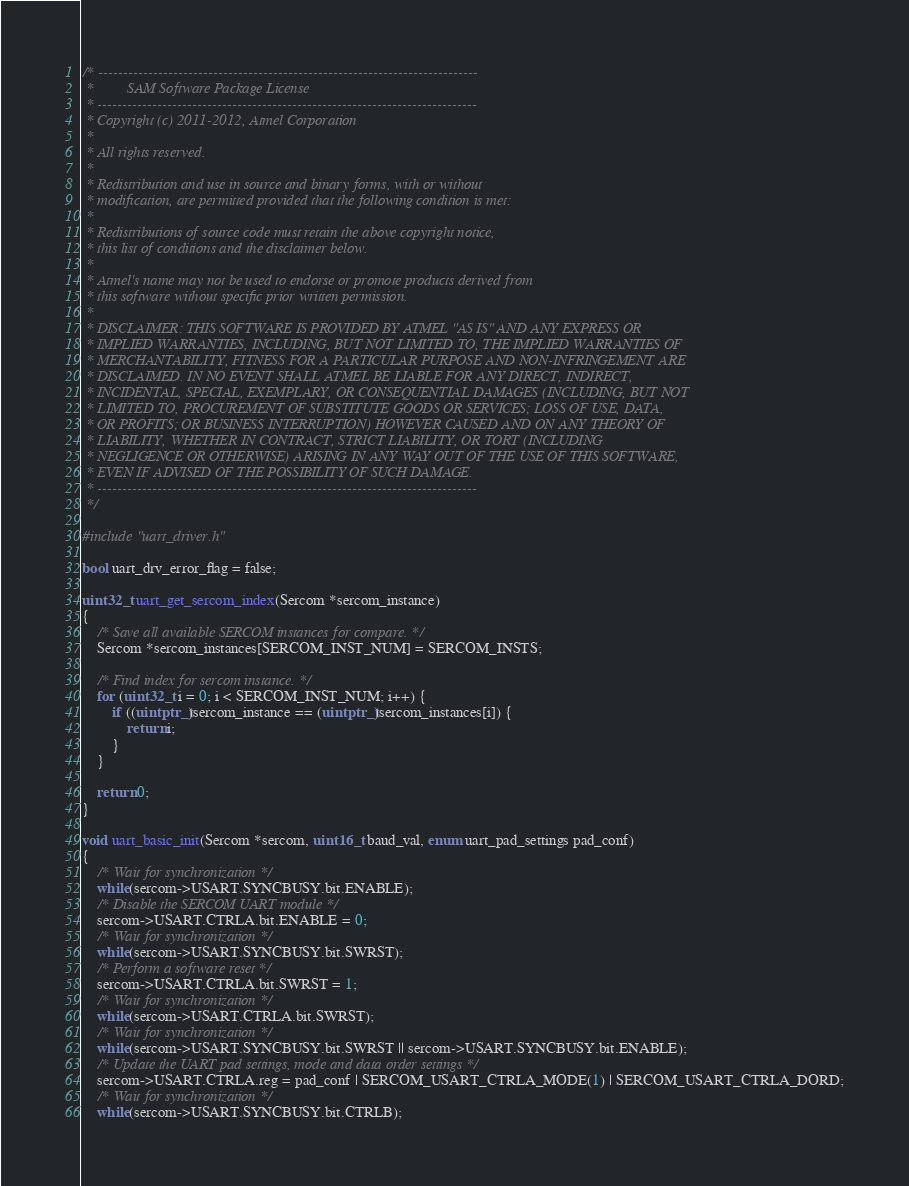Convert code to text. <code><loc_0><loc_0><loc_500><loc_500><_C_>/* ----------------------------------------------------------------------------
 *         SAM Software Package License
 * ----------------------------------------------------------------------------
 * Copyright (c) 2011-2012, Atmel Corporation
 *
 * All rights reserved.
 *
 * Redistribution and use in source and binary forms, with or without
 * modification, are permitted provided that the following condition is met:
 *
 * Redistributions of source code must retain the above copyright notice,
 * this list of conditions and the disclaimer below.
 *
 * Atmel's name may not be used to endorse or promote products derived from
 * this software without specific prior written permission.
 *
 * DISCLAIMER: THIS SOFTWARE IS PROVIDED BY ATMEL "AS IS" AND ANY EXPRESS OR
 * IMPLIED WARRANTIES, INCLUDING, BUT NOT LIMITED TO, THE IMPLIED WARRANTIES OF
 * MERCHANTABILITY, FITNESS FOR A PARTICULAR PURPOSE AND NON-INFRINGEMENT ARE
 * DISCLAIMED. IN NO EVENT SHALL ATMEL BE LIABLE FOR ANY DIRECT, INDIRECT,
 * INCIDENTAL, SPECIAL, EXEMPLARY, OR CONSEQUENTIAL DAMAGES (INCLUDING, BUT NOT
 * LIMITED TO, PROCUREMENT OF SUBSTITUTE GOODS OR SERVICES; LOSS OF USE, DATA,
 * OR PROFITS; OR BUSINESS INTERRUPTION) HOWEVER CAUSED AND ON ANY THEORY OF
 * LIABILITY, WHETHER IN CONTRACT, STRICT LIABILITY, OR TORT (INCLUDING
 * NEGLIGENCE OR OTHERWISE) ARISING IN ANY WAY OUT OF THE USE OF THIS SOFTWARE,
 * EVEN IF ADVISED OF THE POSSIBILITY OF SUCH DAMAGE.
 * ----------------------------------------------------------------------------
 */

#include "uart_driver.h"

bool uart_drv_error_flag = false;

uint32_t uart_get_sercom_index(Sercom *sercom_instance)
{
	/* Save all available SERCOM instances for compare. */
	Sercom *sercom_instances[SERCOM_INST_NUM] = SERCOM_INSTS;

	/* Find index for sercom instance. */
	for (uint32_t i = 0; i < SERCOM_INST_NUM; i++) {
		if ((uintptr_t)sercom_instance == (uintptr_t)sercom_instances[i]) {
			return i;
		}
	}

	return 0;
}

void uart_basic_init(Sercom *sercom, uint16_t baud_val, enum uart_pad_settings pad_conf)
{
	/* Wait for synchronization */
	while(sercom->USART.SYNCBUSY.bit.ENABLE);
	/* Disable the SERCOM UART module */
	sercom->USART.CTRLA.bit.ENABLE = 0;
	/* Wait for synchronization */
	while(sercom->USART.SYNCBUSY.bit.SWRST);
	/* Perform a software reset */
	sercom->USART.CTRLA.bit.SWRST = 1;
	/* Wait for synchronization */
	while(sercom->USART.CTRLA.bit.SWRST);
	/* Wait for synchronization */
	while(sercom->USART.SYNCBUSY.bit.SWRST || sercom->USART.SYNCBUSY.bit.ENABLE);
	/* Update the UART pad settings, mode and data order settings */
	sercom->USART.CTRLA.reg = pad_conf | SERCOM_USART_CTRLA_MODE(1) | SERCOM_USART_CTRLA_DORD;
	/* Wait for synchronization */
	while(sercom->USART.SYNCBUSY.bit.CTRLB);</code> 